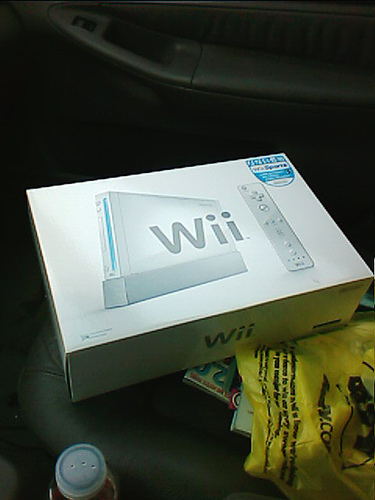<image>How much does it cost, according to the bag? The cost according to the bag is unclear. It can be '$100', '70.99', '200 dollars', or '2.00'. Is there a Wii in the box? I am not sure if there is a Wii in the box. It can be both yes and no. How much does it cost, according to the bag? I don't know how much it costs according to the bag. There is no price mentioned. Is there a Wii in the box? I don't know if there is a Wii in the box. It is possible that there is a Wii inside. 